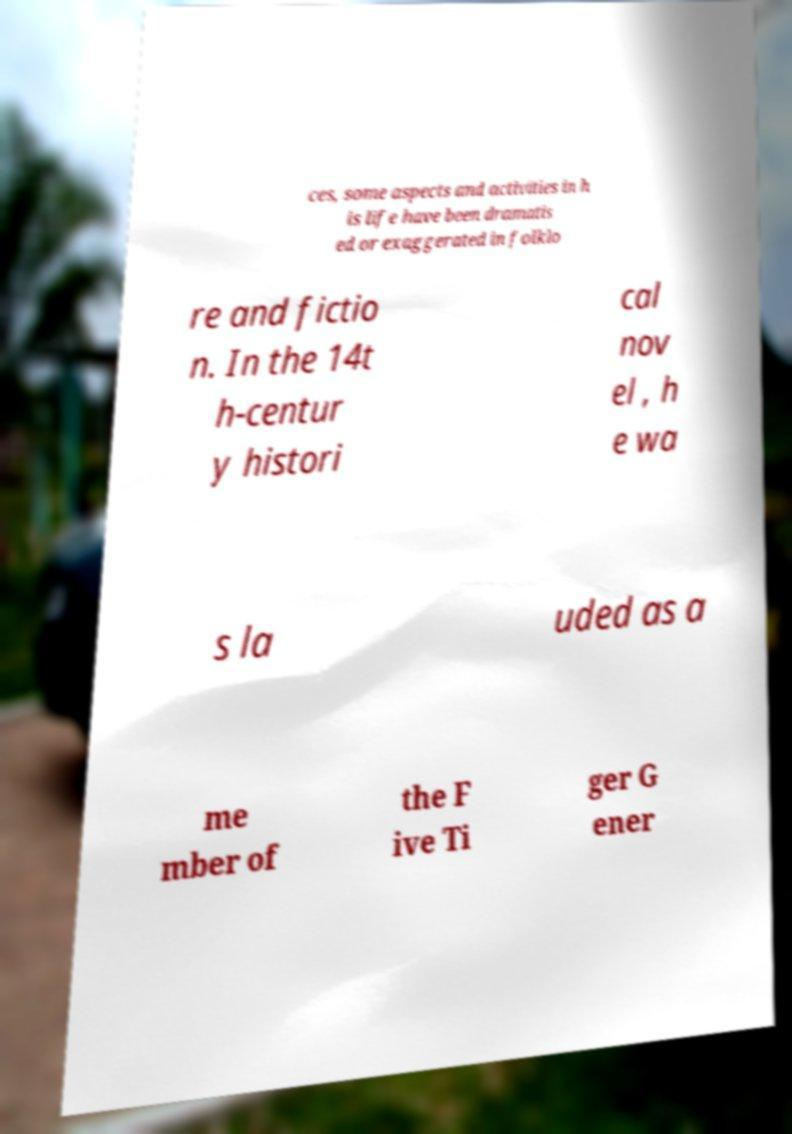Can you accurately transcribe the text from the provided image for me? ces, some aspects and activities in h is life have been dramatis ed or exaggerated in folklo re and fictio n. In the 14t h-centur y histori cal nov el , h e wa s la uded as a me mber of the F ive Ti ger G ener 